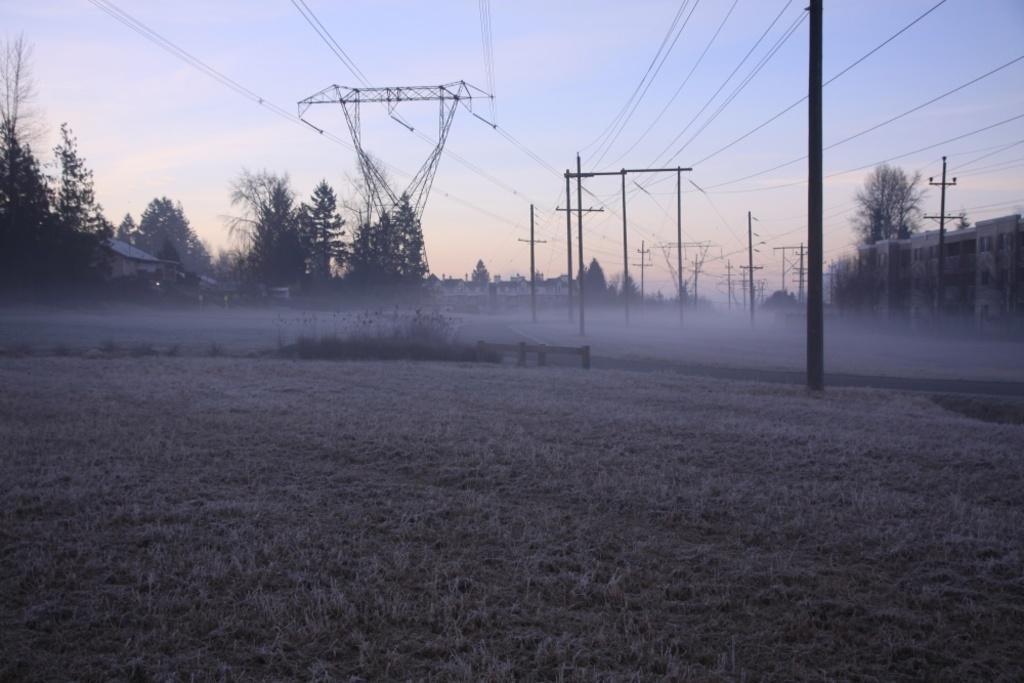In one or two sentences, can you explain what this image depicts? In this picture I can see there is some grass, plants and there is a road here. There is a building on to right and there are electric poles, towers with cables and there are few trees on to left and the sky is clear. 